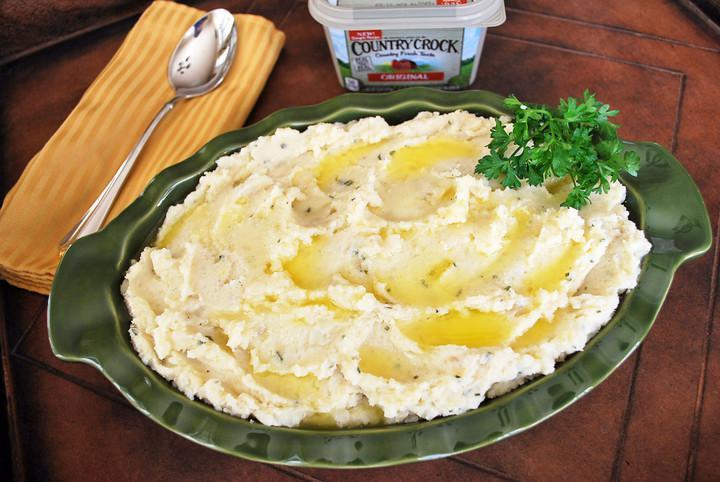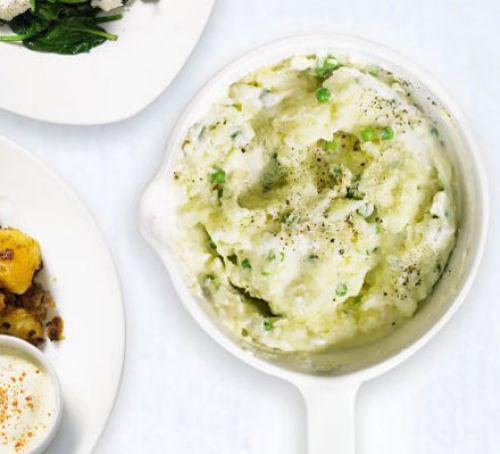The first image is the image on the left, the second image is the image on the right. For the images displayed, is the sentence "In one image a round white bowl of mashed potatoes is garnished with chives, while a second image shows mashed potatoes with a green garnish served in a dark dish." factually correct? Answer yes or no. Yes. The first image is the image on the left, the second image is the image on the right. Evaluate the accuracy of this statement regarding the images: "An image shows a round container of food with green peas in a pile on the very top.". Is it true? Answer yes or no. No. 